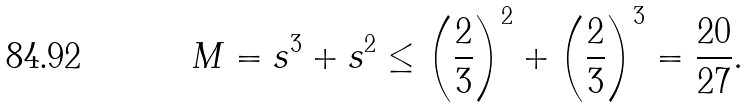<formula> <loc_0><loc_0><loc_500><loc_500>M = s ^ { 3 } + s ^ { 2 } \leq \left ( \frac { 2 } { 3 } \right ) ^ { 2 } + \left ( \frac { 2 } { 3 } \right ) ^ { 3 } = \frac { 2 0 } { 2 7 } .</formula> 